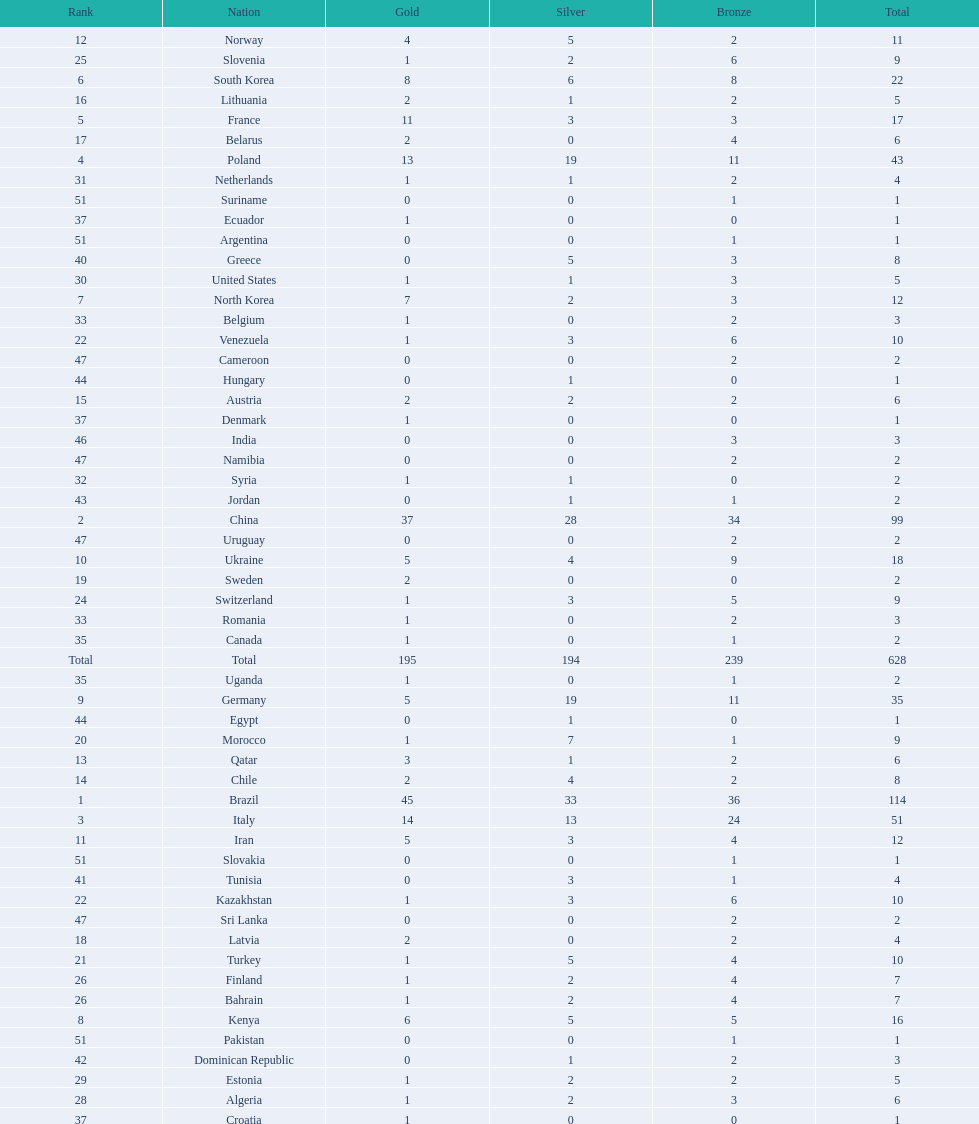Which type of medal does belarus not have? Silver. 